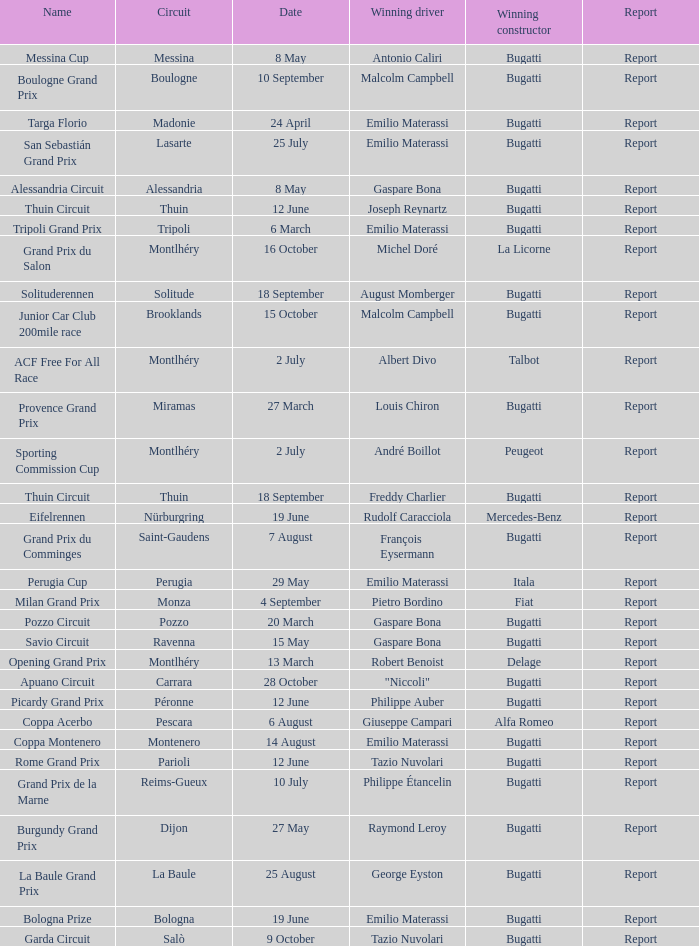When did Gaspare Bona win the Pozzo Circuit? 20 March. 